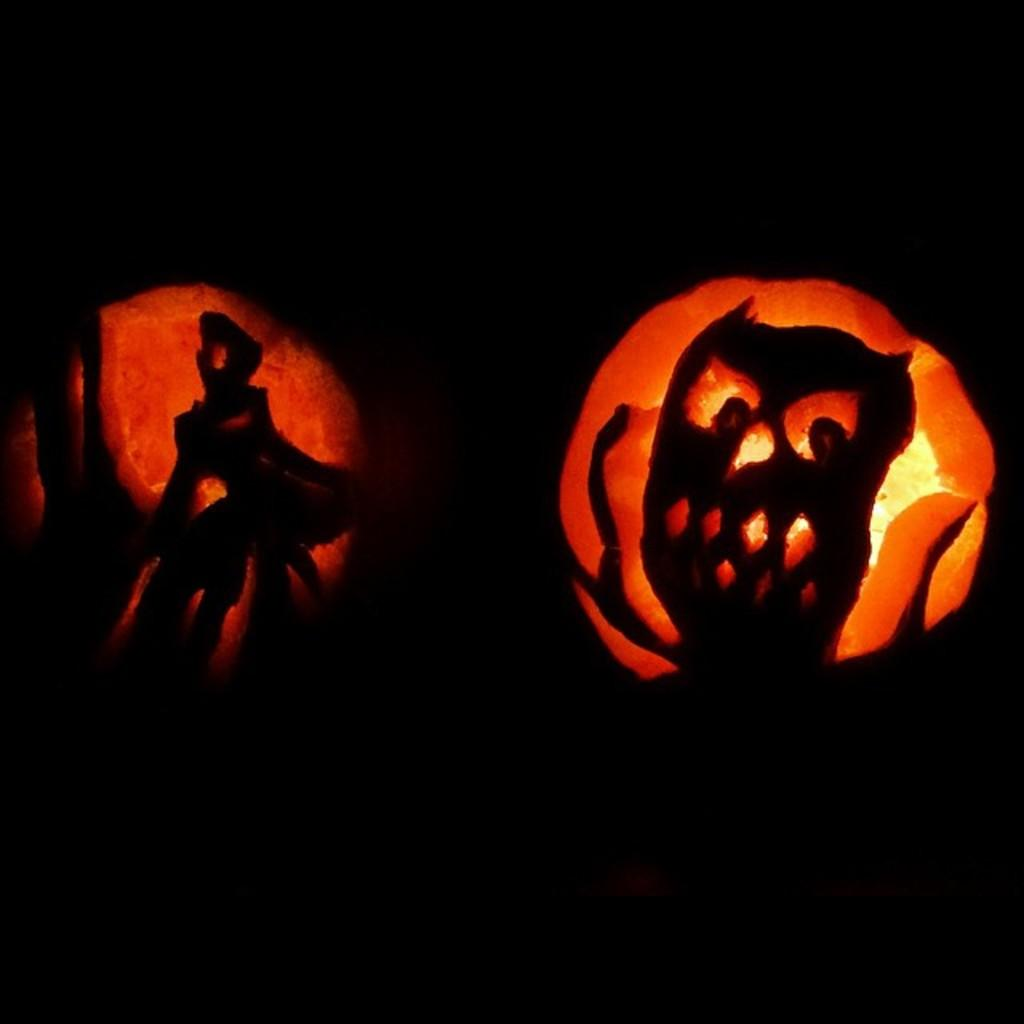What can be seen in the image? There are two jack-o-lanterns in the image. Can you describe the background of the image? The background of the image is blurred. What knowledge does the spy uncle have about the jack-o-lanterns in the image? There is no mention of a spy or an uncle in the image, so it is not possible to determine what knowledge they might have about the jack-o-lanterns. 